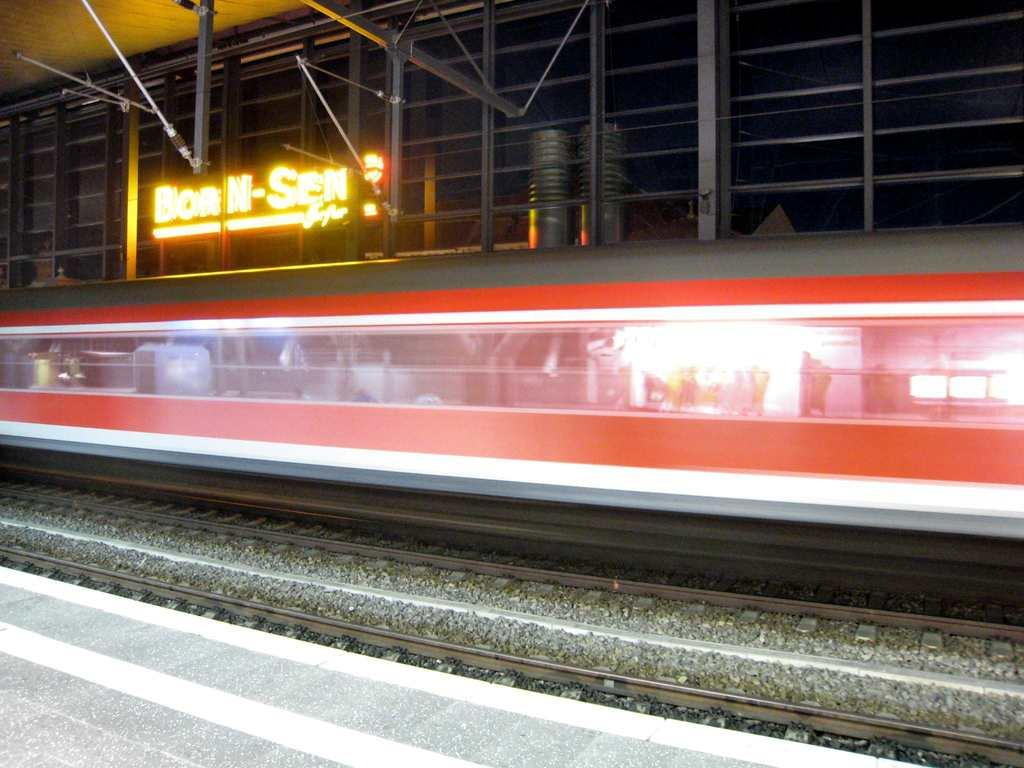What is the main subject of the image? The main subject of the image is a train. Where is the train located in the image? The train is on a train track. What can be seen in the image besides the train? The train tracks, a footpath, text or labels, and iron grills are visible in the image. What type of sock is hanging on the iron grills in the image? There is no sock present in the image; only a train, train tracks, a footpath, text or labels, and iron grills are visible. 